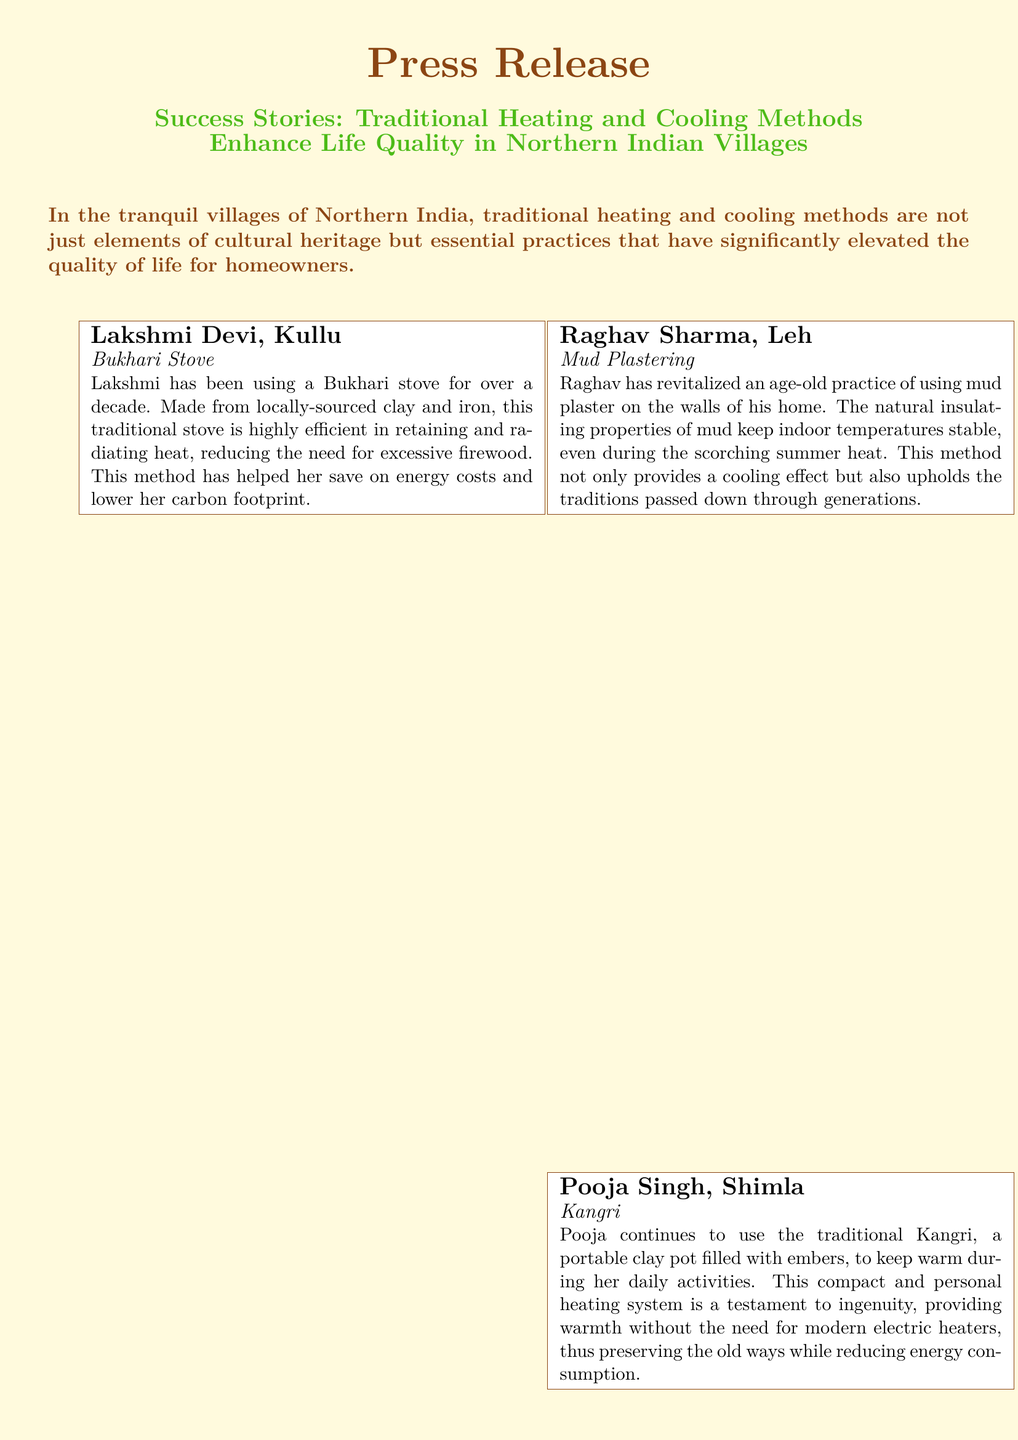what traditional method does Lakshmi Devi use for heating? Lakshmi Devi uses a Bukhari stove for heating, which is made from locally-sourced clay and iron.
Answer: Bukhari stove what is Raghav Sharma’s method for cooling his home? Raghav Sharma uses mud plastering on the walls of his home to keep indoor temperatures stable during summer.
Answer: Mud plastering how long has Pooja Singh been using the Kangri? The document mentions Pooja has been using the Kangri for her daily activities, but it does not specify the duration.
Answer: Not specified what is one benefit of Manoj Kumar's green roofing? One benefit of green roofing is that it acts as a natural air conditioner, keeping the house cool in summer and warm in winter.
Answer: Natural air conditioner how do traditional methods impact the carbon footprint according to the document? The use of traditional methods like the Bukhari stove helps to lower the carbon footprint by reducing the need for excessive firewood.
Answer: Lower carbon footprint what organization can be contacted for more information? The organization mentioned for contact is "Traditional Homes of Northern India."
Answer: Traditional Homes of Northern India where is the press release focused? The press release focuses on villages located in Northern India.
Answer: Northern Indian villages what personal heating system does Pooja Singh use? Pooja Singh uses the traditional Kangri as her personal heating system.
Answer: Kangri 